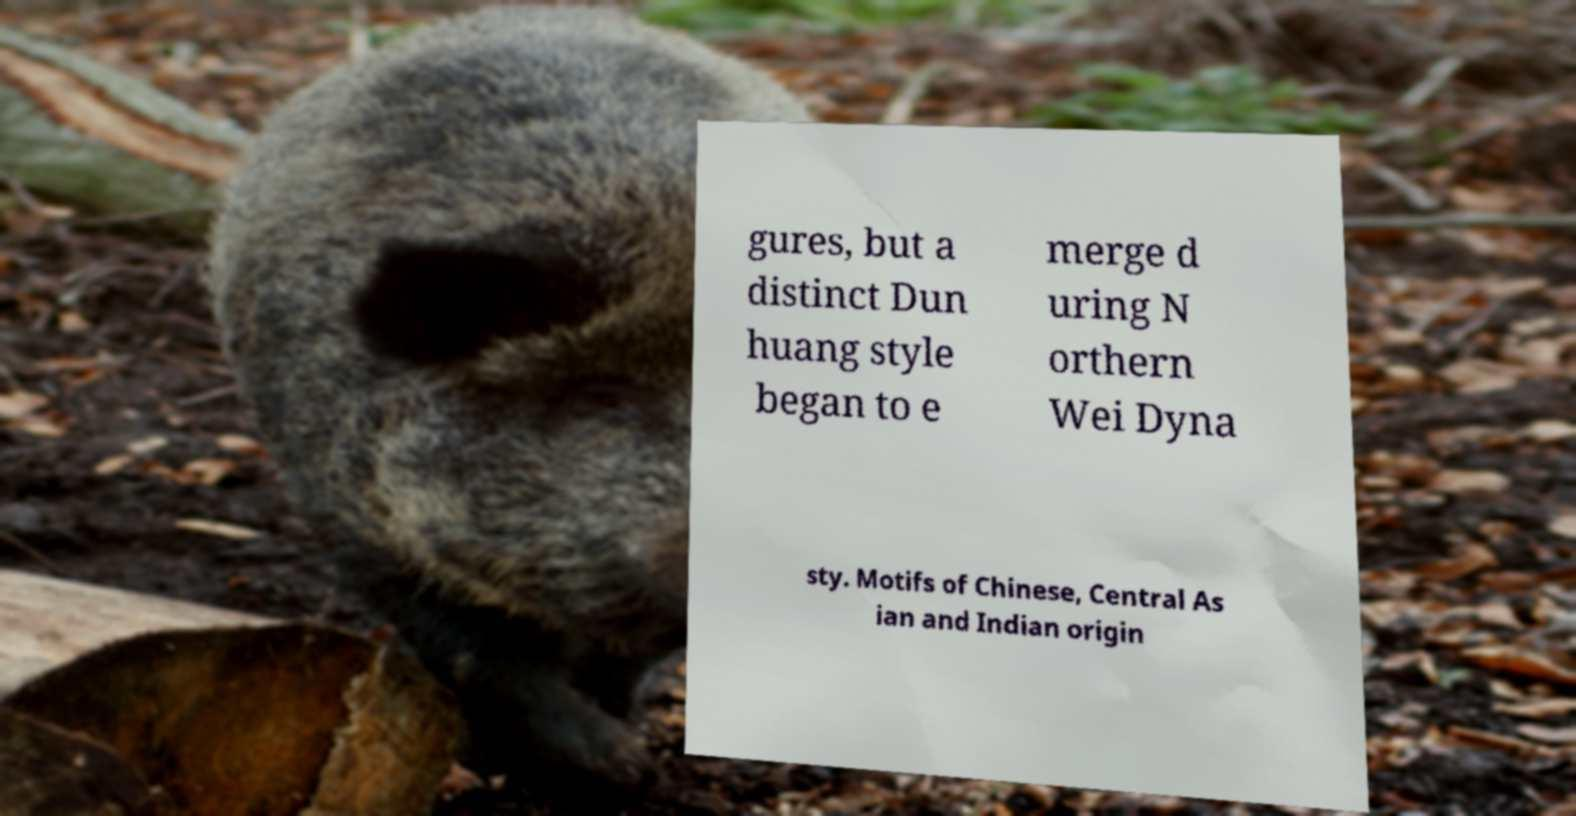Can you accurately transcribe the text from the provided image for me? gures, but a distinct Dun huang style began to e merge d uring N orthern Wei Dyna sty. Motifs of Chinese, Central As ian and Indian origin 